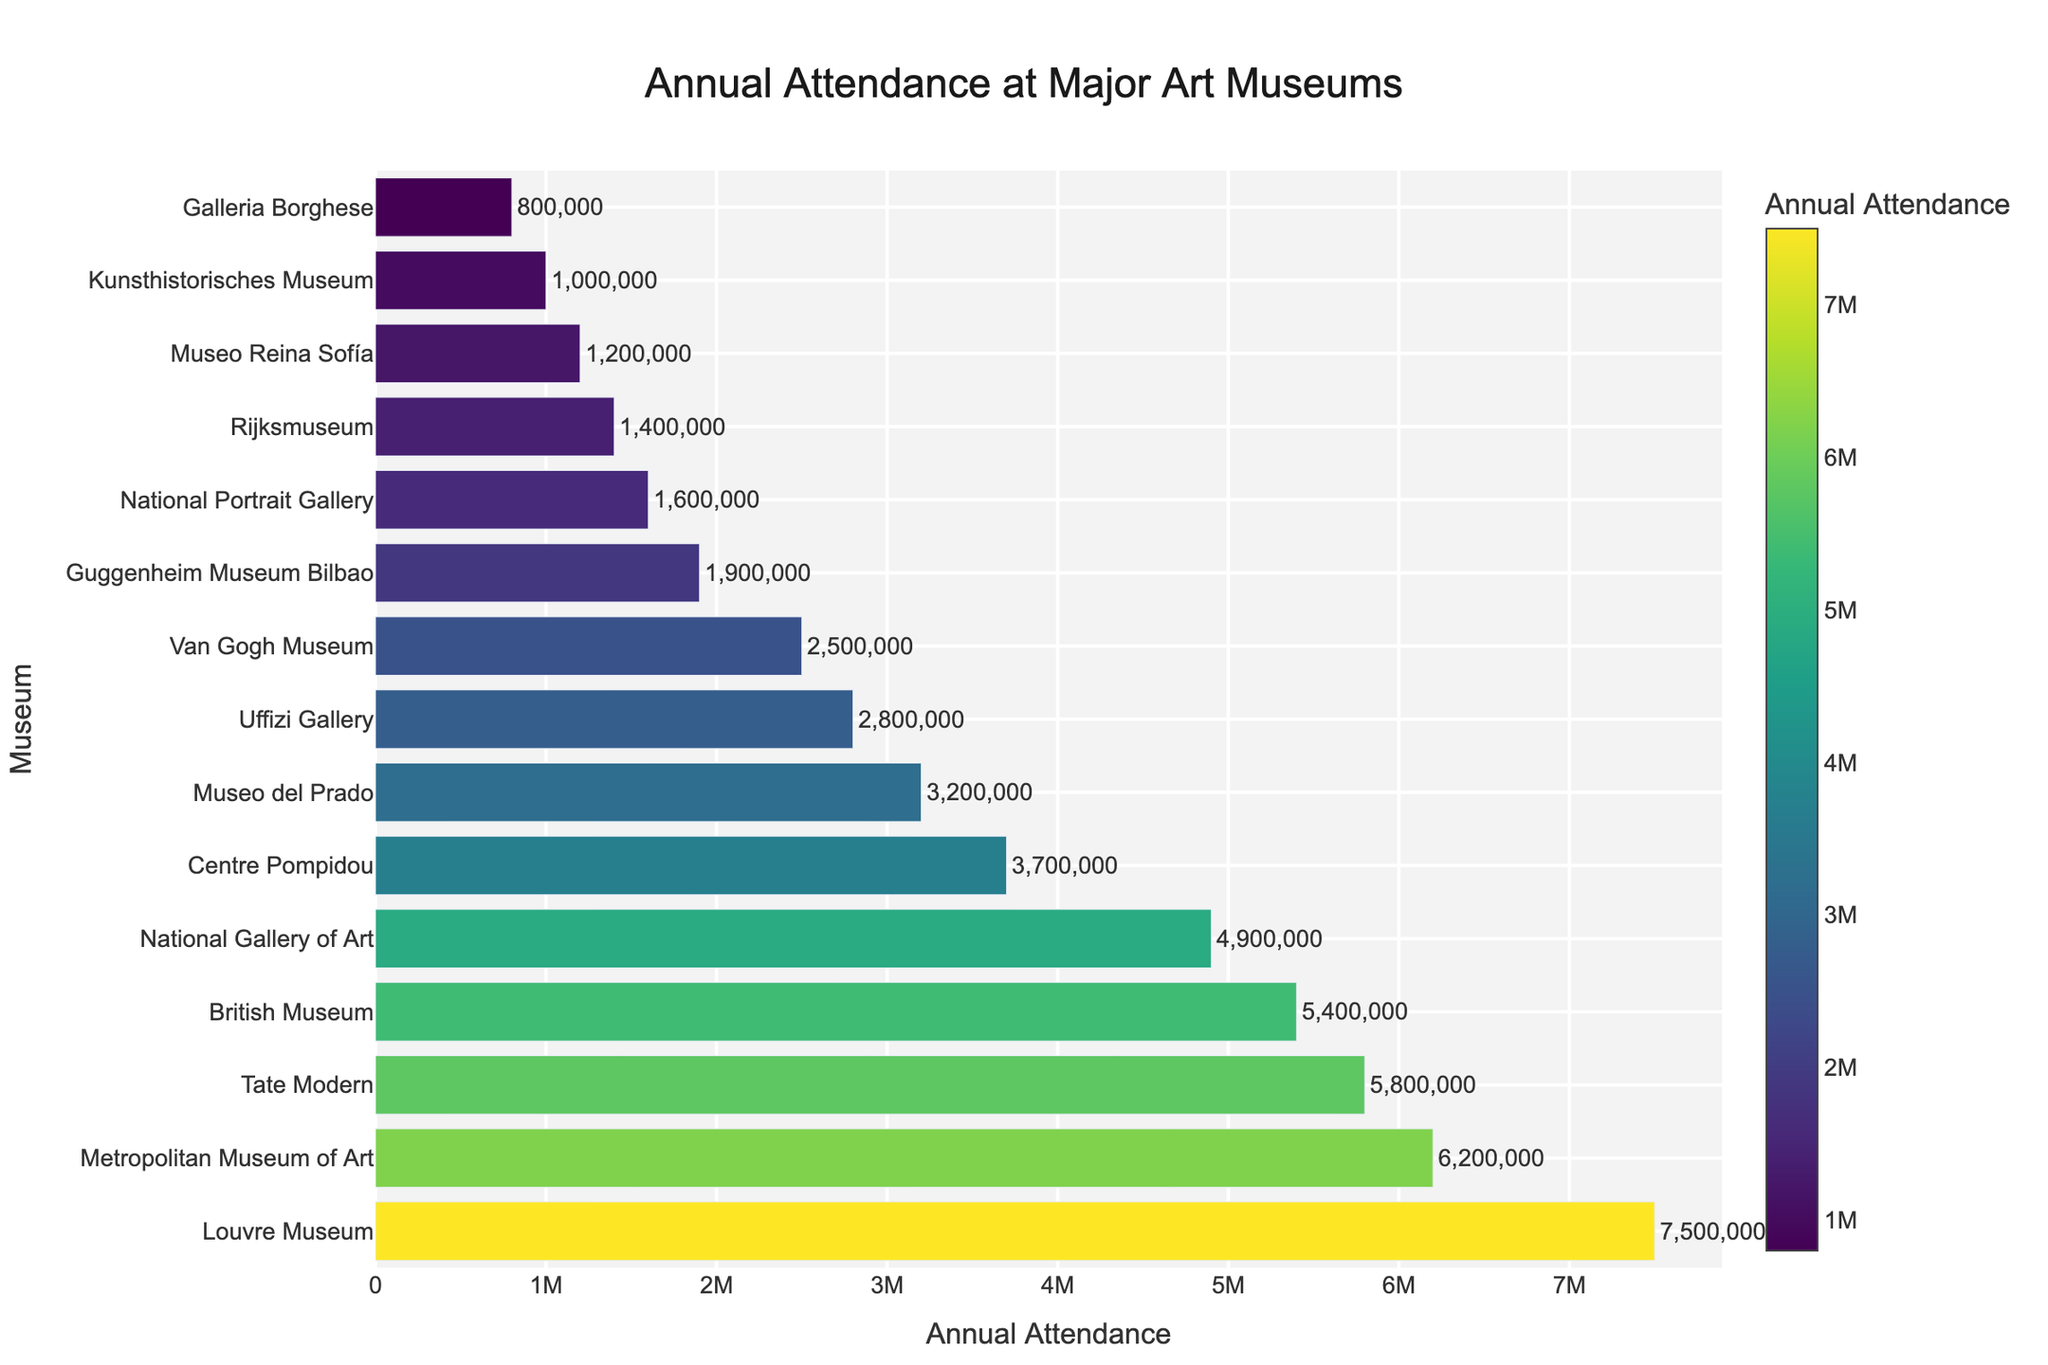Which museum has the highest annual attendance? The bar representing the Louvre Museum is the longest and has the highest value on the x-axis, indicating it has the highest annual attendance.
Answer: Louvre Museum Which museum has the lowest annual attendance? The bar representing the Galleria Borghese is the shortest and has the lowest value on the x-axis, indicating it has the lowest annual attendance.
Answer: Galleria Borghese What is the total attendance for the top three museums combined? The top three museums are the Louvre Museum (7,500,000), the Metropolitan Museum of Art (6,200,000), and the Tate Modern (5,800,000). Adding these values gives us 7,500,000 + 6,200,000 + 5,800,000 = 19,500,000.
Answer: 19,500,000 What is the average annual attendance of the museums in the dataset? Adding the attendance figures for all the museums gives: 7,500,000 + 6,200,000 + 5,800,000 + 5,400,000 + 4,900,000 + 3,700,000 + 3,200,000 + 2,800,000 + 2,500,000 + 1,900,000 + 1,600,000 + 1,400,000 + 1,200,000 + 1,000,000 + 800,000 = 49,000,000. Dividing this total by the number of museums (15) gives an average of 49,000,000 / 15 = 3,266,667.
Answer: 3,266,667 How many museums have annual attendance figures greater than 3 million? Counting the number of bars where the attendance value on the x-axis is greater than 3,000,000: there are 7 museums (Louvre Museum, Metropolitan Museum of Art, Tate Modern, British Museum, National Gallery of Art, Centre Pompidou, Museo del Prado).
Answer: 7 By what margin does the Louvre Museum's attendance exceed that of the British Museum? The annual attendance for the Louvre Museum is 7,500,000 and for the British Museum is 5,400,000. The difference is 7,500,000 - 5,400,000 = 2,100,000.
Answer: 2,100,000 What is the combined annual attendance for museums with less than 2 million visitors? The museums with less than 2 million visitors are the Guggenheim Museum Bilbao (1,900,000), National Portrait Gallery (1,600,000), Rijksmuseum (1,400,000), Museo Reina Sofía (1,200,000), Kunsthistorisches Museum (1,000,000), and Galleria Borghese (800,000). The combined attendance is 1,900,000 + 1,600,000 + 1,400,000 + 1,200,000 + 1,000,000 + 800,000 = 7,900,000.
Answer: 7,900,000 Which museum has an attendance figure close to the median of the dataset? There are 15 museums, so the median will be the 8th value when sorted in descending order. The attendance figures in descending order are: 7,500,000, 6,200,000, 5,800,000, 5,400,000, 4,900,000, 3,700,000, 3,200,000, 2,800,000 (Uffizi Gallery). Therefore, the Uffizi Gallery has the median attendance figure.
Answer: Uffizi Gallery What is the difference in attendance between the Tate Modern and the Uffizi Gallery? The annual attendance for the Tate Modern is 5,800,000 and for the Uffizi Gallery is 2,800,000. The difference is 5,800,000 - 2,800,000 = 3,000,000.
Answer: 3,000,000 